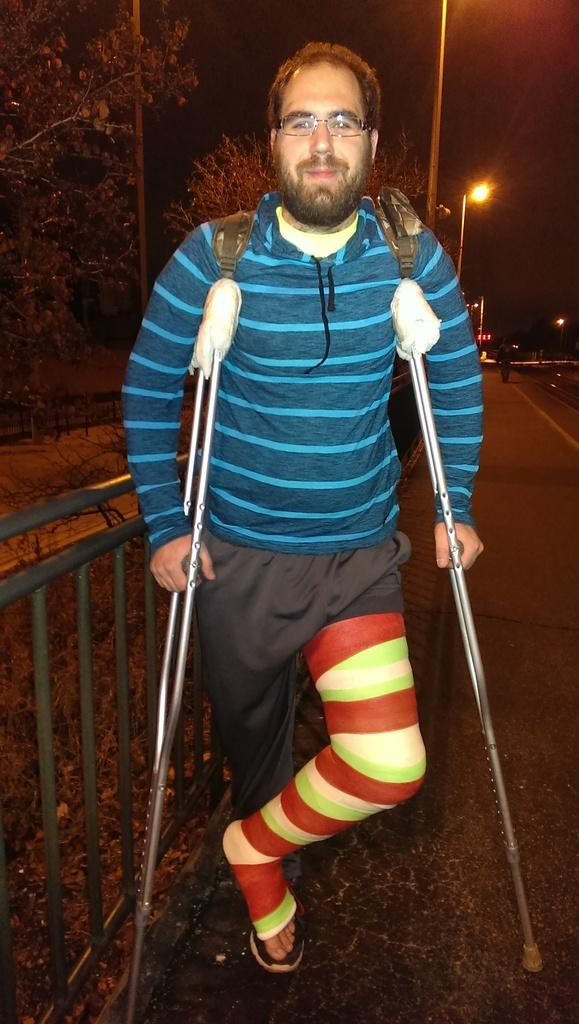What is the person in the image doing? The person is standing in the image and holding two sticks. What is the person wearing? The person is wearing a blue shirt and brown pants. What can be seen in the background of the image? There are light poles, trees, and the sky visible in the background of the image. Reasoning: Let'g: Let's think step by step in order to produce the conversation. We start by identifying the main subject in the image, which is the person standing and holding two sticks. Then, we describe the person's clothing to provide more detail about their appearance. Finally, we mention the background elements to give a sense of the setting and context of the image. Absurd Question/Answer: Is the person in the image sinking into quicksand while wearing a yoke? There is no quicksand or yoke present in the image. The person is standing on a solid surface and not wearing any yoke. 